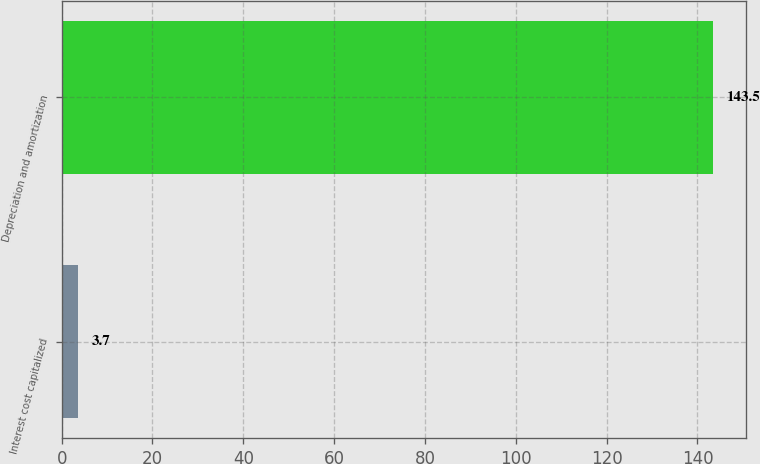<chart> <loc_0><loc_0><loc_500><loc_500><bar_chart><fcel>Interest cost capitalized<fcel>Depreciation and amortization<nl><fcel>3.7<fcel>143.5<nl></chart> 